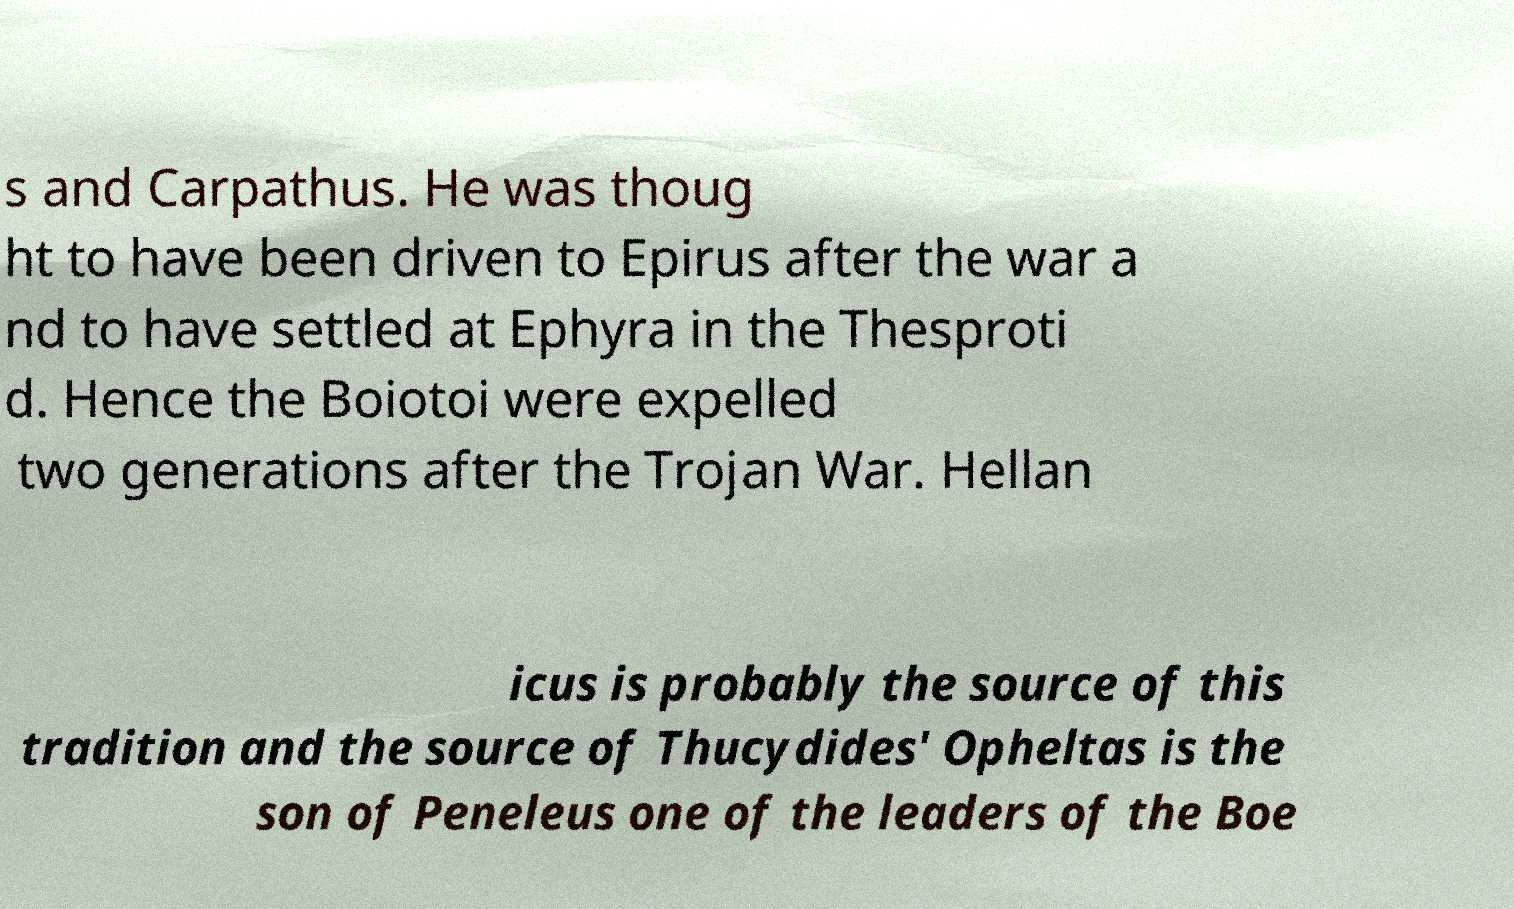Can you accurately transcribe the text from the provided image for me? s and Carpathus. He was thoug ht to have been driven to Epirus after the war a nd to have settled at Ephyra in the Thesproti d. Hence the Boiotoi were expelled two generations after the Trojan War. Hellan icus is probably the source of this tradition and the source of Thucydides' Opheltas is the son of Peneleus one of the leaders of the Boe 